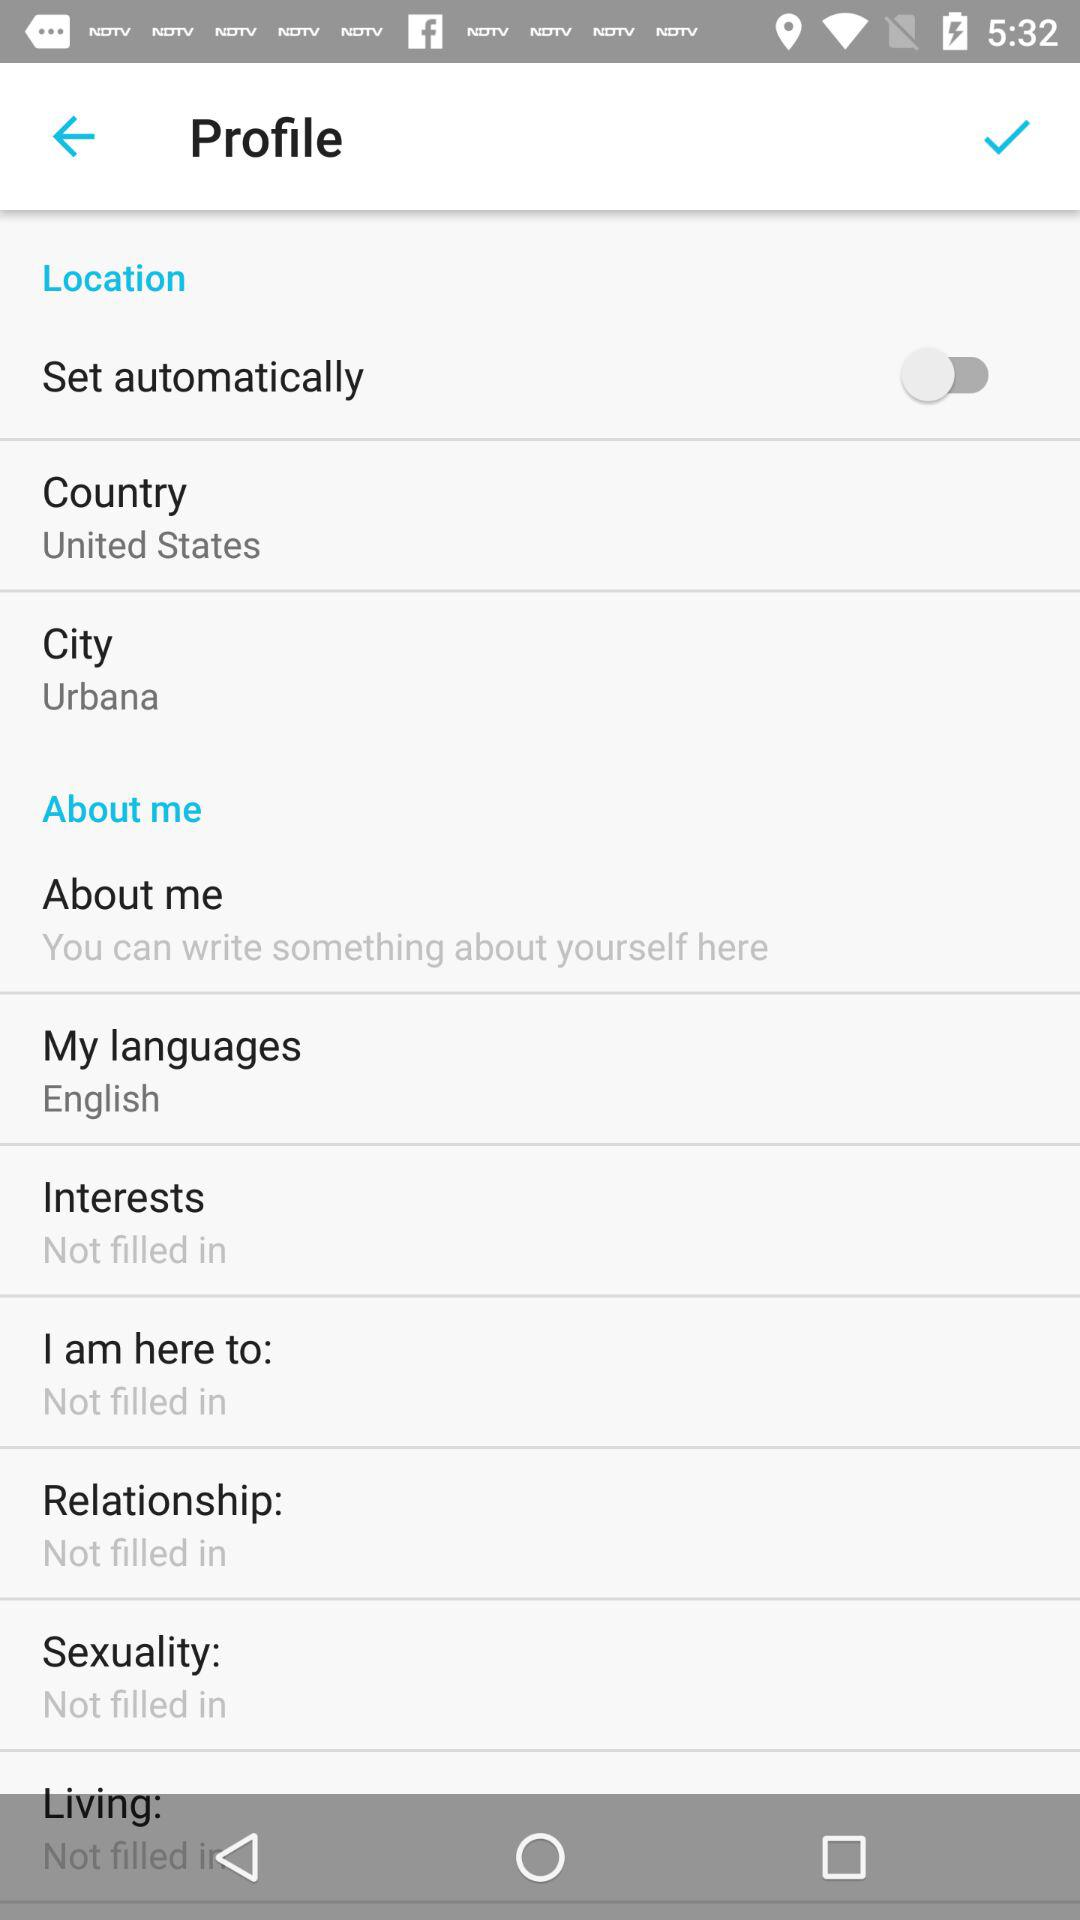What is the status of "Set automatically"? The status of "Set automatically" is "off". 